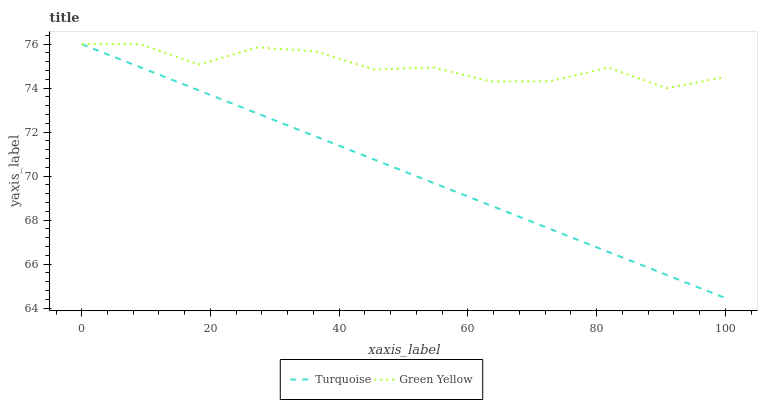Does Turquoise have the minimum area under the curve?
Answer yes or no. Yes. Does Green Yellow have the maximum area under the curve?
Answer yes or no. Yes. Does Green Yellow have the minimum area under the curve?
Answer yes or no. No. Is Turquoise the smoothest?
Answer yes or no. Yes. Is Green Yellow the roughest?
Answer yes or no. Yes. Is Green Yellow the smoothest?
Answer yes or no. No. Does Green Yellow have the lowest value?
Answer yes or no. No. 